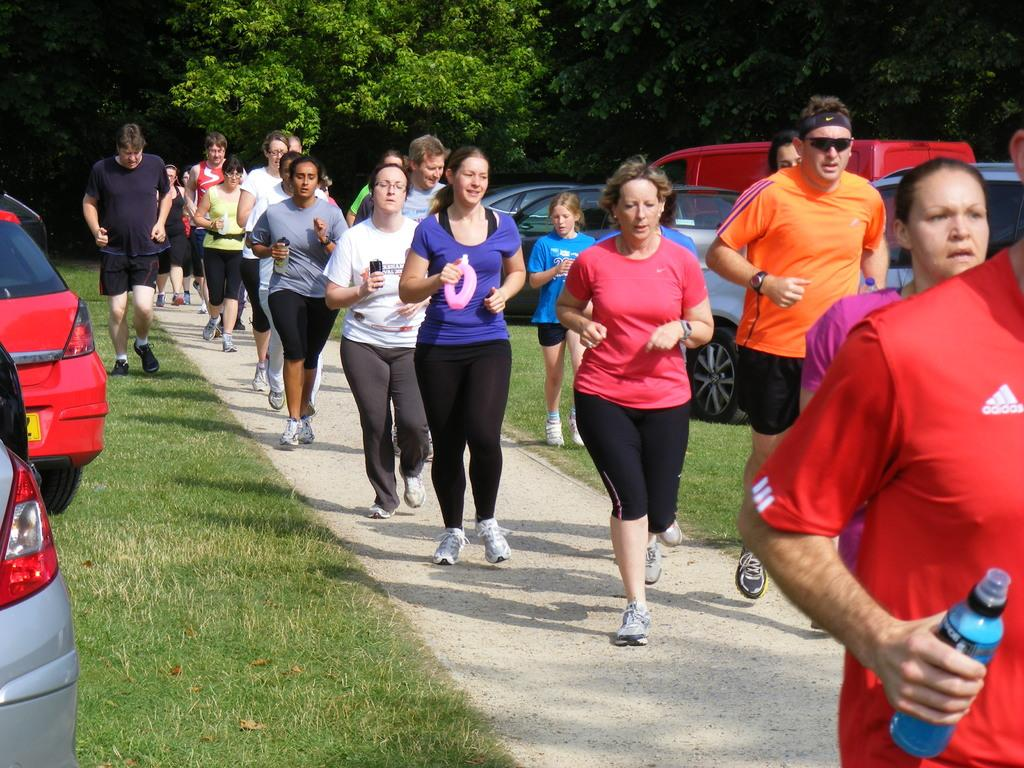What are the people in the image doing? The people in the image are jogging on the road. What can be seen in the background of the image? There are trees visible in the background of the image. Where are the cars parked in the image? The cars are parked on the grass in the image. Where is the playground located in the image? There is no playground present in the image. What type of cable can be seen connecting the trees in the image? There is no cable connecting the trees in the image. 